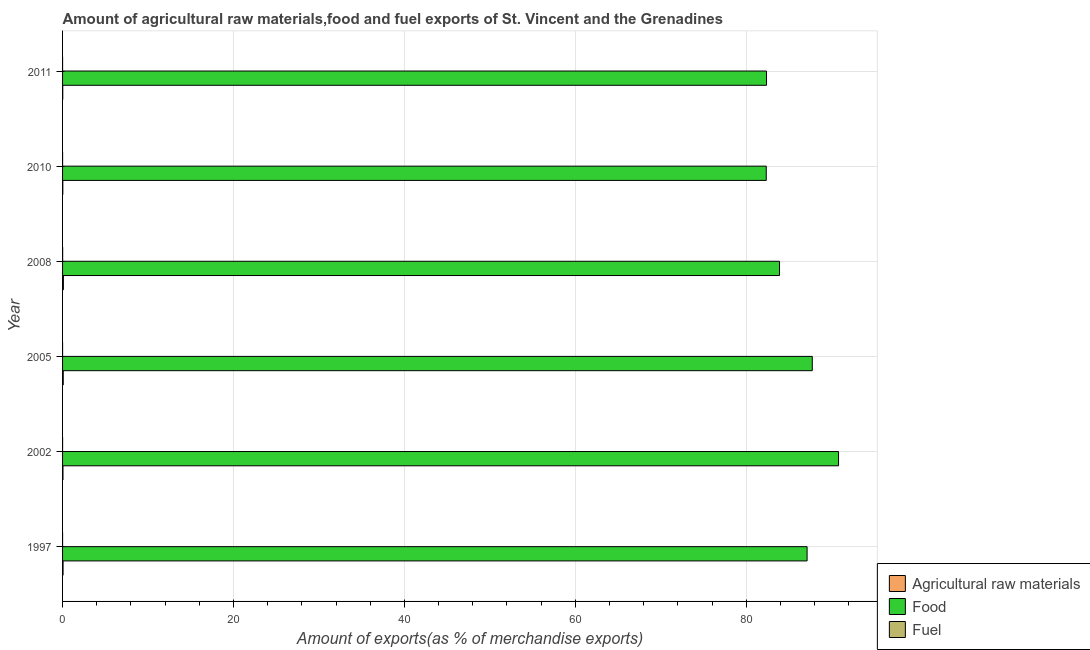Are the number of bars per tick equal to the number of legend labels?
Provide a succinct answer. Yes. Are the number of bars on each tick of the Y-axis equal?
Keep it short and to the point. Yes. How many bars are there on the 3rd tick from the top?
Your answer should be compact. 3. What is the percentage of raw materials exports in 2008?
Ensure brevity in your answer.  0.1. Across all years, what is the maximum percentage of fuel exports?
Offer a terse response. 0.01. Across all years, what is the minimum percentage of raw materials exports?
Provide a succinct answer. 0.02. In which year was the percentage of fuel exports minimum?
Your answer should be compact. 1997. What is the total percentage of fuel exports in the graph?
Your response must be concise. 0.01. What is the difference between the percentage of food exports in 1997 and that in 2011?
Your answer should be very brief. 4.75. What is the difference between the percentage of fuel exports in 2002 and the percentage of food exports in 2008?
Offer a very short reply. -83.89. What is the average percentage of fuel exports per year?
Your answer should be compact. 0. In the year 1997, what is the difference between the percentage of fuel exports and percentage of raw materials exports?
Make the answer very short. -0.06. What is the ratio of the percentage of fuel exports in 2008 to that in 2010?
Your response must be concise. 9.34. Is the percentage of fuel exports in 2008 less than that in 2010?
Provide a succinct answer. No. Is the difference between the percentage of food exports in 2010 and 2011 greater than the difference between the percentage of fuel exports in 2010 and 2011?
Provide a succinct answer. No. What is the difference between the highest and the second highest percentage of fuel exports?
Provide a succinct answer. 0.01. What is the difference between the highest and the lowest percentage of raw materials exports?
Your answer should be very brief. 0.08. Is the sum of the percentage of raw materials exports in 2005 and 2010 greater than the maximum percentage of fuel exports across all years?
Your answer should be compact. Yes. What does the 3rd bar from the top in 2005 represents?
Your answer should be compact. Agricultural raw materials. What does the 3rd bar from the bottom in 2005 represents?
Your answer should be compact. Fuel. How many years are there in the graph?
Ensure brevity in your answer.  6. What is the difference between two consecutive major ticks on the X-axis?
Provide a succinct answer. 20. Where does the legend appear in the graph?
Make the answer very short. Bottom right. What is the title of the graph?
Make the answer very short. Amount of agricultural raw materials,food and fuel exports of St. Vincent and the Grenadines. Does "Hydroelectric sources" appear as one of the legend labels in the graph?
Provide a short and direct response. No. What is the label or title of the X-axis?
Give a very brief answer. Amount of exports(as % of merchandise exports). What is the Amount of exports(as % of merchandise exports) of Agricultural raw materials in 1997?
Your response must be concise. 0.06. What is the Amount of exports(as % of merchandise exports) of Food in 1997?
Your answer should be very brief. 87.12. What is the Amount of exports(as % of merchandise exports) of Fuel in 1997?
Make the answer very short. 4.24255707588636e-5. What is the Amount of exports(as % of merchandise exports) of Agricultural raw materials in 2002?
Ensure brevity in your answer.  0.05. What is the Amount of exports(as % of merchandise exports) in Food in 2002?
Your answer should be very brief. 90.8. What is the Amount of exports(as % of merchandise exports) of Fuel in 2002?
Keep it short and to the point. 0. What is the Amount of exports(as % of merchandise exports) in Agricultural raw materials in 2005?
Keep it short and to the point. 0.08. What is the Amount of exports(as % of merchandise exports) of Food in 2005?
Your answer should be compact. 87.72. What is the Amount of exports(as % of merchandise exports) in Fuel in 2005?
Ensure brevity in your answer.  0. What is the Amount of exports(as % of merchandise exports) in Agricultural raw materials in 2008?
Keep it short and to the point. 0.1. What is the Amount of exports(as % of merchandise exports) of Food in 2008?
Keep it short and to the point. 83.89. What is the Amount of exports(as % of merchandise exports) in Fuel in 2008?
Ensure brevity in your answer.  0.01. What is the Amount of exports(as % of merchandise exports) of Agricultural raw materials in 2010?
Your answer should be compact. 0.03. What is the Amount of exports(as % of merchandise exports) of Food in 2010?
Keep it short and to the point. 82.34. What is the Amount of exports(as % of merchandise exports) of Fuel in 2010?
Your response must be concise. 0. What is the Amount of exports(as % of merchandise exports) of Agricultural raw materials in 2011?
Your answer should be very brief. 0.02. What is the Amount of exports(as % of merchandise exports) in Food in 2011?
Provide a short and direct response. 82.37. What is the Amount of exports(as % of merchandise exports) in Fuel in 2011?
Ensure brevity in your answer.  0. Across all years, what is the maximum Amount of exports(as % of merchandise exports) of Agricultural raw materials?
Offer a terse response. 0.1. Across all years, what is the maximum Amount of exports(as % of merchandise exports) of Food?
Keep it short and to the point. 90.8. Across all years, what is the maximum Amount of exports(as % of merchandise exports) of Fuel?
Ensure brevity in your answer.  0.01. Across all years, what is the minimum Amount of exports(as % of merchandise exports) in Agricultural raw materials?
Offer a very short reply. 0.02. Across all years, what is the minimum Amount of exports(as % of merchandise exports) in Food?
Your answer should be compact. 82.34. Across all years, what is the minimum Amount of exports(as % of merchandise exports) of Fuel?
Offer a very short reply. 4.24255707588636e-5. What is the total Amount of exports(as % of merchandise exports) of Agricultural raw materials in the graph?
Your answer should be very brief. 0.33. What is the total Amount of exports(as % of merchandise exports) in Food in the graph?
Provide a succinct answer. 514.23. What is the total Amount of exports(as % of merchandise exports) in Fuel in the graph?
Ensure brevity in your answer.  0.01. What is the difference between the Amount of exports(as % of merchandise exports) of Agricultural raw materials in 1997 and that in 2002?
Give a very brief answer. 0.01. What is the difference between the Amount of exports(as % of merchandise exports) in Food in 1997 and that in 2002?
Offer a very short reply. -3.68. What is the difference between the Amount of exports(as % of merchandise exports) in Fuel in 1997 and that in 2002?
Ensure brevity in your answer.  -0. What is the difference between the Amount of exports(as % of merchandise exports) of Agricultural raw materials in 1997 and that in 2005?
Your answer should be compact. -0.02. What is the difference between the Amount of exports(as % of merchandise exports) of Food in 1997 and that in 2005?
Offer a very short reply. -0.61. What is the difference between the Amount of exports(as % of merchandise exports) in Fuel in 1997 and that in 2005?
Make the answer very short. -0. What is the difference between the Amount of exports(as % of merchandise exports) in Agricultural raw materials in 1997 and that in 2008?
Give a very brief answer. -0.04. What is the difference between the Amount of exports(as % of merchandise exports) of Food in 1997 and that in 2008?
Your answer should be compact. 3.23. What is the difference between the Amount of exports(as % of merchandise exports) of Fuel in 1997 and that in 2008?
Offer a terse response. -0.01. What is the difference between the Amount of exports(as % of merchandise exports) in Agricultural raw materials in 1997 and that in 2010?
Your answer should be very brief. 0.03. What is the difference between the Amount of exports(as % of merchandise exports) of Food in 1997 and that in 2010?
Ensure brevity in your answer.  4.78. What is the difference between the Amount of exports(as % of merchandise exports) of Fuel in 1997 and that in 2010?
Your response must be concise. -0. What is the difference between the Amount of exports(as % of merchandise exports) of Agricultural raw materials in 1997 and that in 2011?
Provide a succinct answer. 0.04. What is the difference between the Amount of exports(as % of merchandise exports) in Food in 1997 and that in 2011?
Your answer should be compact. 4.75. What is the difference between the Amount of exports(as % of merchandise exports) of Fuel in 1997 and that in 2011?
Your answer should be very brief. -0. What is the difference between the Amount of exports(as % of merchandise exports) of Agricultural raw materials in 2002 and that in 2005?
Offer a very short reply. -0.03. What is the difference between the Amount of exports(as % of merchandise exports) in Food in 2002 and that in 2005?
Keep it short and to the point. 3.07. What is the difference between the Amount of exports(as % of merchandise exports) of Fuel in 2002 and that in 2005?
Your answer should be very brief. 0. What is the difference between the Amount of exports(as % of merchandise exports) of Agricultural raw materials in 2002 and that in 2008?
Offer a very short reply. -0.05. What is the difference between the Amount of exports(as % of merchandise exports) in Food in 2002 and that in 2008?
Make the answer very short. 6.91. What is the difference between the Amount of exports(as % of merchandise exports) of Fuel in 2002 and that in 2008?
Offer a terse response. -0.01. What is the difference between the Amount of exports(as % of merchandise exports) of Agricultural raw materials in 2002 and that in 2010?
Offer a terse response. 0.02. What is the difference between the Amount of exports(as % of merchandise exports) of Food in 2002 and that in 2010?
Keep it short and to the point. 8.46. What is the difference between the Amount of exports(as % of merchandise exports) of Fuel in 2002 and that in 2010?
Offer a terse response. 0. What is the difference between the Amount of exports(as % of merchandise exports) in Agricultural raw materials in 2002 and that in 2011?
Provide a succinct answer. 0.03. What is the difference between the Amount of exports(as % of merchandise exports) in Food in 2002 and that in 2011?
Offer a very short reply. 8.43. What is the difference between the Amount of exports(as % of merchandise exports) in Fuel in 2002 and that in 2011?
Your response must be concise. 0. What is the difference between the Amount of exports(as % of merchandise exports) in Agricultural raw materials in 2005 and that in 2008?
Give a very brief answer. -0.02. What is the difference between the Amount of exports(as % of merchandise exports) of Food in 2005 and that in 2008?
Offer a terse response. 3.83. What is the difference between the Amount of exports(as % of merchandise exports) in Fuel in 2005 and that in 2008?
Offer a terse response. -0.01. What is the difference between the Amount of exports(as % of merchandise exports) of Agricultural raw materials in 2005 and that in 2010?
Give a very brief answer. 0.05. What is the difference between the Amount of exports(as % of merchandise exports) of Food in 2005 and that in 2010?
Your answer should be compact. 5.38. What is the difference between the Amount of exports(as % of merchandise exports) in Fuel in 2005 and that in 2010?
Offer a very short reply. -0. What is the difference between the Amount of exports(as % of merchandise exports) of Agricultural raw materials in 2005 and that in 2011?
Offer a very short reply. 0.06. What is the difference between the Amount of exports(as % of merchandise exports) in Food in 2005 and that in 2011?
Offer a very short reply. 5.35. What is the difference between the Amount of exports(as % of merchandise exports) of Fuel in 2005 and that in 2011?
Make the answer very short. -0. What is the difference between the Amount of exports(as % of merchandise exports) in Agricultural raw materials in 2008 and that in 2010?
Your answer should be compact. 0.07. What is the difference between the Amount of exports(as % of merchandise exports) in Food in 2008 and that in 2010?
Provide a short and direct response. 1.55. What is the difference between the Amount of exports(as % of merchandise exports) in Fuel in 2008 and that in 2010?
Your response must be concise. 0.01. What is the difference between the Amount of exports(as % of merchandise exports) of Agricultural raw materials in 2008 and that in 2011?
Offer a very short reply. 0.08. What is the difference between the Amount of exports(as % of merchandise exports) in Food in 2008 and that in 2011?
Provide a succinct answer. 1.52. What is the difference between the Amount of exports(as % of merchandise exports) in Fuel in 2008 and that in 2011?
Provide a succinct answer. 0.01. What is the difference between the Amount of exports(as % of merchandise exports) in Agricultural raw materials in 2010 and that in 2011?
Your answer should be compact. 0.01. What is the difference between the Amount of exports(as % of merchandise exports) in Food in 2010 and that in 2011?
Offer a terse response. -0.03. What is the difference between the Amount of exports(as % of merchandise exports) of Fuel in 2010 and that in 2011?
Keep it short and to the point. 0. What is the difference between the Amount of exports(as % of merchandise exports) in Agricultural raw materials in 1997 and the Amount of exports(as % of merchandise exports) in Food in 2002?
Keep it short and to the point. -90.74. What is the difference between the Amount of exports(as % of merchandise exports) of Agricultural raw materials in 1997 and the Amount of exports(as % of merchandise exports) of Fuel in 2002?
Ensure brevity in your answer.  0.06. What is the difference between the Amount of exports(as % of merchandise exports) in Food in 1997 and the Amount of exports(as % of merchandise exports) in Fuel in 2002?
Give a very brief answer. 87.11. What is the difference between the Amount of exports(as % of merchandise exports) in Agricultural raw materials in 1997 and the Amount of exports(as % of merchandise exports) in Food in 2005?
Provide a short and direct response. -87.66. What is the difference between the Amount of exports(as % of merchandise exports) in Agricultural raw materials in 1997 and the Amount of exports(as % of merchandise exports) in Fuel in 2005?
Give a very brief answer. 0.06. What is the difference between the Amount of exports(as % of merchandise exports) of Food in 1997 and the Amount of exports(as % of merchandise exports) of Fuel in 2005?
Provide a short and direct response. 87.11. What is the difference between the Amount of exports(as % of merchandise exports) in Agricultural raw materials in 1997 and the Amount of exports(as % of merchandise exports) in Food in 2008?
Your answer should be very brief. -83.83. What is the difference between the Amount of exports(as % of merchandise exports) of Agricultural raw materials in 1997 and the Amount of exports(as % of merchandise exports) of Fuel in 2008?
Provide a succinct answer. 0.05. What is the difference between the Amount of exports(as % of merchandise exports) in Food in 1997 and the Amount of exports(as % of merchandise exports) in Fuel in 2008?
Keep it short and to the point. 87.11. What is the difference between the Amount of exports(as % of merchandise exports) in Agricultural raw materials in 1997 and the Amount of exports(as % of merchandise exports) in Food in 2010?
Your answer should be very brief. -82.28. What is the difference between the Amount of exports(as % of merchandise exports) of Agricultural raw materials in 1997 and the Amount of exports(as % of merchandise exports) of Fuel in 2010?
Offer a terse response. 0.06. What is the difference between the Amount of exports(as % of merchandise exports) in Food in 1997 and the Amount of exports(as % of merchandise exports) in Fuel in 2010?
Your response must be concise. 87.11. What is the difference between the Amount of exports(as % of merchandise exports) in Agricultural raw materials in 1997 and the Amount of exports(as % of merchandise exports) in Food in 2011?
Keep it short and to the point. -82.31. What is the difference between the Amount of exports(as % of merchandise exports) of Agricultural raw materials in 1997 and the Amount of exports(as % of merchandise exports) of Fuel in 2011?
Provide a short and direct response. 0.06. What is the difference between the Amount of exports(as % of merchandise exports) in Food in 1997 and the Amount of exports(as % of merchandise exports) in Fuel in 2011?
Offer a very short reply. 87.11. What is the difference between the Amount of exports(as % of merchandise exports) of Agricultural raw materials in 2002 and the Amount of exports(as % of merchandise exports) of Food in 2005?
Ensure brevity in your answer.  -87.67. What is the difference between the Amount of exports(as % of merchandise exports) in Agricultural raw materials in 2002 and the Amount of exports(as % of merchandise exports) in Fuel in 2005?
Offer a very short reply. 0.05. What is the difference between the Amount of exports(as % of merchandise exports) of Food in 2002 and the Amount of exports(as % of merchandise exports) of Fuel in 2005?
Ensure brevity in your answer.  90.8. What is the difference between the Amount of exports(as % of merchandise exports) in Agricultural raw materials in 2002 and the Amount of exports(as % of merchandise exports) in Food in 2008?
Provide a succinct answer. -83.84. What is the difference between the Amount of exports(as % of merchandise exports) in Agricultural raw materials in 2002 and the Amount of exports(as % of merchandise exports) in Fuel in 2008?
Give a very brief answer. 0.04. What is the difference between the Amount of exports(as % of merchandise exports) in Food in 2002 and the Amount of exports(as % of merchandise exports) in Fuel in 2008?
Keep it short and to the point. 90.79. What is the difference between the Amount of exports(as % of merchandise exports) of Agricultural raw materials in 2002 and the Amount of exports(as % of merchandise exports) of Food in 2010?
Your answer should be very brief. -82.29. What is the difference between the Amount of exports(as % of merchandise exports) in Agricultural raw materials in 2002 and the Amount of exports(as % of merchandise exports) in Fuel in 2010?
Give a very brief answer. 0.05. What is the difference between the Amount of exports(as % of merchandise exports) in Food in 2002 and the Amount of exports(as % of merchandise exports) in Fuel in 2010?
Your response must be concise. 90.8. What is the difference between the Amount of exports(as % of merchandise exports) of Agricultural raw materials in 2002 and the Amount of exports(as % of merchandise exports) of Food in 2011?
Provide a succinct answer. -82.32. What is the difference between the Amount of exports(as % of merchandise exports) of Agricultural raw materials in 2002 and the Amount of exports(as % of merchandise exports) of Fuel in 2011?
Provide a succinct answer. 0.05. What is the difference between the Amount of exports(as % of merchandise exports) of Food in 2002 and the Amount of exports(as % of merchandise exports) of Fuel in 2011?
Keep it short and to the point. 90.8. What is the difference between the Amount of exports(as % of merchandise exports) of Agricultural raw materials in 2005 and the Amount of exports(as % of merchandise exports) of Food in 2008?
Provide a short and direct response. -83.81. What is the difference between the Amount of exports(as % of merchandise exports) of Agricultural raw materials in 2005 and the Amount of exports(as % of merchandise exports) of Fuel in 2008?
Your answer should be very brief. 0.07. What is the difference between the Amount of exports(as % of merchandise exports) in Food in 2005 and the Amount of exports(as % of merchandise exports) in Fuel in 2008?
Keep it short and to the point. 87.71. What is the difference between the Amount of exports(as % of merchandise exports) of Agricultural raw materials in 2005 and the Amount of exports(as % of merchandise exports) of Food in 2010?
Your response must be concise. -82.26. What is the difference between the Amount of exports(as % of merchandise exports) in Agricultural raw materials in 2005 and the Amount of exports(as % of merchandise exports) in Fuel in 2010?
Offer a very short reply. 0.08. What is the difference between the Amount of exports(as % of merchandise exports) in Food in 2005 and the Amount of exports(as % of merchandise exports) in Fuel in 2010?
Your answer should be compact. 87.72. What is the difference between the Amount of exports(as % of merchandise exports) of Agricultural raw materials in 2005 and the Amount of exports(as % of merchandise exports) of Food in 2011?
Offer a very short reply. -82.29. What is the difference between the Amount of exports(as % of merchandise exports) in Agricultural raw materials in 2005 and the Amount of exports(as % of merchandise exports) in Fuel in 2011?
Give a very brief answer. 0.08. What is the difference between the Amount of exports(as % of merchandise exports) of Food in 2005 and the Amount of exports(as % of merchandise exports) of Fuel in 2011?
Your answer should be very brief. 87.72. What is the difference between the Amount of exports(as % of merchandise exports) of Agricultural raw materials in 2008 and the Amount of exports(as % of merchandise exports) of Food in 2010?
Ensure brevity in your answer.  -82.24. What is the difference between the Amount of exports(as % of merchandise exports) in Agricultural raw materials in 2008 and the Amount of exports(as % of merchandise exports) in Fuel in 2010?
Your answer should be compact. 0.1. What is the difference between the Amount of exports(as % of merchandise exports) in Food in 2008 and the Amount of exports(as % of merchandise exports) in Fuel in 2010?
Make the answer very short. 83.89. What is the difference between the Amount of exports(as % of merchandise exports) in Agricultural raw materials in 2008 and the Amount of exports(as % of merchandise exports) in Food in 2011?
Provide a succinct answer. -82.27. What is the difference between the Amount of exports(as % of merchandise exports) of Agricultural raw materials in 2008 and the Amount of exports(as % of merchandise exports) of Fuel in 2011?
Your answer should be very brief. 0.1. What is the difference between the Amount of exports(as % of merchandise exports) of Food in 2008 and the Amount of exports(as % of merchandise exports) of Fuel in 2011?
Your response must be concise. 83.89. What is the difference between the Amount of exports(as % of merchandise exports) in Agricultural raw materials in 2010 and the Amount of exports(as % of merchandise exports) in Food in 2011?
Your response must be concise. -82.34. What is the difference between the Amount of exports(as % of merchandise exports) of Agricultural raw materials in 2010 and the Amount of exports(as % of merchandise exports) of Fuel in 2011?
Offer a very short reply. 0.03. What is the difference between the Amount of exports(as % of merchandise exports) of Food in 2010 and the Amount of exports(as % of merchandise exports) of Fuel in 2011?
Your answer should be compact. 82.34. What is the average Amount of exports(as % of merchandise exports) in Agricultural raw materials per year?
Ensure brevity in your answer.  0.06. What is the average Amount of exports(as % of merchandise exports) of Food per year?
Your answer should be compact. 85.7. What is the average Amount of exports(as % of merchandise exports) of Fuel per year?
Offer a terse response. 0. In the year 1997, what is the difference between the Amount of exports(as % of merchandise exports) of Agricultural raw materials and Amount of exports(as % of merchandise exports) of Food?
Offer a very short reply. -87.06. In the year 1997, what is the difference between the Amount of exports(as % of merchandise exports) of Agricultural raw materials and Amount of exports(as % of merchandise exports) of Fuel?
Ensure brevity in your answer.  0.06. In the year 1997, what is the difference between the Amount of exports(as % of merchandise exports) in Food and Amount of exports(as % of merchandise exports) in Fuel?
Give a very brief answer. 87.12. In the year 2002, what is the difference between the Amount of exports(as % of merchandise exports) in Agricultural raw materials and Amount of exports(as % of merchandise exports) in Food?
Ensure brevity in your answer.  -90.75. In the year 2002, what is the difference between the Amount of exports(as % of merchandise exports) in Agricultural raw materials and Amount of exports(as % of merchandise exports) in Fuel?
Your answer should be very brief. 0.05. In the year 2002, what is the difference between the Amount of exports(as % of merchandise exports) of Food and Amount of exports(as % of merchandise exports) of Fuel?
Your answer should be very brief. 90.79. In the year 2005, what is the difference between the Amount of exports(as % of merchandise exports) of Agricultural raw materials and Amount of exports(as % of merchandise exports) of Food?
Make the answer very short. -87.64. In the year 2005, what is the difference between the Amount of exports(as % of merchandise exports) in Agricultural raw materials and Amount of exports(as % of merchandise exports) in Fuel?
Keep it short and to the point. 0.08. In the year 2005, what is the difference between the Amount of exports(as % of merchandise exports) in Food and Amount of exports(as % of merchandise exports) in Fuel?
Make the answer very short. 87.72. In the year 2008, what is the difference between the Amount of exports(as % of merchandise exports) in Agricultural raw materials and Amount of exports(as % of merchandise exports) in Food?
Keep it short and to the point. -83.79. In the year 2008, what is the difference between the Amount of exports(as % of merchandise exports) in Agricultural raw materials and Amount of exports(as % of merchandise exports) in Fuel?
Your response must be concise. 0.09. In the year 2008, what is the difference between the Amount of exports(as % of merchandise exports) of Food and Amount of exports(as % of merchandise exports) of Fuel?
Your response must be concise. 83.88. In the year 2010, what is the difference between the Amount of exports(as % of merchandise exports) in Agricultural raw materials and Amount of exports(as % of merchandise exports) in Food?
Keep it short and to the point. -82.31. In the year 2010, what is the difference between the Amount of exports(as % of merchandise exports) of Agricultural raw materials and Amount of exports(as % of merchandise exports) of Fuel?
Provide a short and direct response. 0.03. In the year 2010, what is the difference between the Amount of exports(as % of merchandise exports) in Food and Amount of exports(as % of merchandise exports) in Fuel?
Give a very brief answer. 82.34. In the year 2011, what is the difference between the Amount of exports(as % of merchandise exports) in Agricultural raw materials and Amount of exports(as % of merchandise exports) in Food?
Your answer should be compact. -82.35. In the year 2011, what is the difference between the Amount of exports(as % of merchandise exports) of Agricultural raw materials and Amount of exports(as % of merchandise exports) of Fuel?
Make the answer very short. 0.02. In the year 2011, what is the difference between the Amount of exports(as % of merchandise exports) of Food and Amount of exports(as % of merchandise exports) of Fuel?
Make the answer very short. 82.37. What is the ratio of the Amount of exports(as % of merchandise exports) of Agricultural raw materials in 1997 to that in 2002?
Ensure brevity in your answer.  1.2. What is the ratio of the Amount of exports(as % of merchandise exports) of Food in 1997 to that in 2002?
Provide a short and direct response. 0.96. What is the ratio of the Amount of exports(as % of merchandise exports) in Fuel in 1997 to that in 2002?
Make the answer very short. 0.02. What is the ratio of the Amount of exports(as % of merchandise exports) in Agricultural raw materials in 1997 to that in 2005?
Keep it short and to the point. 0.71. What is the ratio of the Amount of exports(as % of merchandise exports) of Fuel in 1997 to that in 2005?
Your response must be concise. 0.13. What is the ratio of the Amount of exports(as % of merchandise exports) in Agricultural raw materials in 1997 to that in 2008?
Your answer should be compact. 0.59. What is the ratio of the Amount of exports(as % of merchandise exports) in Fuel in 1997 to that in 2008?
Your answer should be very brief. 0. What is the ratio of the Amount of exports(as % of merchandise exports) in Agricultural raw materials in 1997 to that in 2010?
Your response must be concise. 1.95. What is the ratio of the Amount of exports(as % of merchandise exports) of Food in 1997 to that in 2010?
Make the answer very short. 1.06. What is the ratio of the Amount of exports(as % of merchandise exports) in Fuel in 1997 to that in 2010?
Offer a very short reply. 0.04. What is the ratio of the Amount of exports(as % of merchandise exports) in Agricultural raw materials in 1997 to that in 2011?
Your response must be concise. 2.76. What is the ratio of the Amount of exports(as % of merchandise exports) of Food in 1997 to that in 2011?
Provide a short and direct response. 1.06. What is the ratio of the Amount of exports(as % of merchandise exports) of Fuel in 1997 to that in 2011?
Offer a very short reply. 0.11. What is the ratio of the Amount of exports(as % of merchandise exports) in Agricultural raw materials in 2002 to that in 2005?
Make the answer very short. 0.59. What is the ratio of the Amount of exports(as % of merchandise exports) in Food in 2002 to that in 2005?
Your response must be concise. 1.03. What is the ratio of the Amount of exports(as % of merchandise exports) of Fuel in 2002 to that in 2005?
Ensure brevity in your answer.  5.42. What is the ratio of the Amount of exports(as % of merchandise exports) in Agricultural raw materials in 2002 to that in 2008?
Make the answer very short. 0.49. What is the ratio of the Amount of exports(as % of merchandise exports) of Food in 2002 to that in 2008?
Your answer should be very brief. 1.08. What is the ratio of the Amount of exports(as % of merchandise exports) of Fuel in 2002 to that in 2008?
Provide a succinct answer. 0.19. What is the ratio of the Amount of exports(as % of merchandise exports) of Agricultural raw materials in 2002 to that in 2010?
Your answer should be compact. 1.63. What is the ratio of the Amount of exports(as % of merchandise exports) of Food in 2002 to that in 2010?
Keep it short and to the point. 1.1. What is the ratio of the Amount of exports(as % of merchandise exports) of Fuel in 2002 to that in 2010?
Offer a terse response. 1.81. What is the ratio of the Amount of exports(as % of merchandise exports) in Agricultural raw materials in 2002 to that in 2011?
Provide a succinct answer. 2.3. What is the ratio of the Amount of exports(as % of merchandise exports) in Food in 2002 to that in 2011?
Make the answer very short. 1.1. What is the ratio of the Amount of exports(as % of merchandise exports) in Fuel in 2002 to that in 2011?
Offer a terse response. 4.43. What is the ratio of the Amount of exports(as % of merchandise exports) in Agricultural raw materials in 2005 to that in 2008?
Offer a very short reply. 0.82. What is the ratio of the Amount of exports(as % of merchandise exports) in Food in 2005 to that in 2008?
Ensure brevity in your answer.  1.05. What is the ratio of the Amount of exports(as % of merchandise exports) of Fuel in 2005 to that in 2008?
Make the answer very short. 0.04. What is the ratio of the Amount of exports(as % of merchandise exports) of Agricultural raw materials in 2005 to that in 2010?
Your response must be concise. 2.74. What is the ratio of the Amount of exports(as % of merchandise exports) of Food in 2005 to that in 2010?
Provide a short and direct response. 1.07. What is the ratio of the Amount of exports(as % of merchandise exports) in Fuel in 2005 to that in 2010?
Provide a short and direct response. 0.33. What is the ratio of the Amount of exports(as % of merchandise exports) of Agricultural raw materials in 2005 to that in 2011?
Your answer should be compact. 3.87. What is the ratio of the Amount of exports(as % of merchandise exports) of Food in 2005 to that in 2011?
Make the answer very short. 1.06. What is the ratio of the Amount of exports(as % of merchandise exports) in Fuel in 2005 to that in 2011?
Your answer should be compact. 0.82. What is the ratio of the Amount of exports(as % of merchandise exports) in Agricultural raw materials in 2008 to that in 2010?
Your answer should be very brief. 3.33. What is the ratio of the Amount of exports(as % of merchandise exports) in Food in 2008 to that in 2010?
Keep it short and to the point. 1.02. What is the ratio of the Amount of exports(as % of merchandise exports) in Fuel in 2008 to that in 2010?
Your response must be concise. 9.34. What is the ratio of the Amount of exports(as % of merchandise exports) in Agricultural raw materials in 2008 to that in 2011?
Provide a succinct answer. 4.7. What is the ratio of the Amount of exports(as % of merchandise exports) in Food in 2008 to that in 2011?
Ensure brevity in your answer.  1.02. What is the ratio of the Amount of exports(as % of merchandise exports) in Fuel in 2008 to that in 2011?
Keep it short and to the point. 22.86. What is the ratio of the Amount of exports(as % of merchandise exports) of Agricultural raw materials in 2010 to that in 2011?
Make the answer very short. 1.41. What is the ratio of the Amount of exports(as % of merchandise exports) of Fuel in 2010 to that in 2011?
Keep it short and to the point. 2.45. What is the difference between the highest and the second highest Amount of exports(as % of merchandise exports) in Agricultural raw materials?
Ensure brevity in your answer.  0.02. What is the difference between the highest and the second highest Amount of exports(as % of merchandise exports) in Food?
Ensure brevity in your answer.  3.07. What is the difference between the highest and the second highest Amount of exports(as % of merchandise exports) in Fuel?
Your answer should be very brief. 0.01. What is the difference between the highest and the lowest Amount of exports(as % of merchandise exports) in Agricultural raw materials?
Offer a terse response. 0.08. What is the difference between the highest and the lowest Amount of exports(as % of merchandise exports) in Food?
Ensure brevity in your answer.  8.46. What is the difference between the highest and the lowest Amount of exports(as % of merchandise exports) in Fuel?
Ensure brevity in your answer.  0.01. 